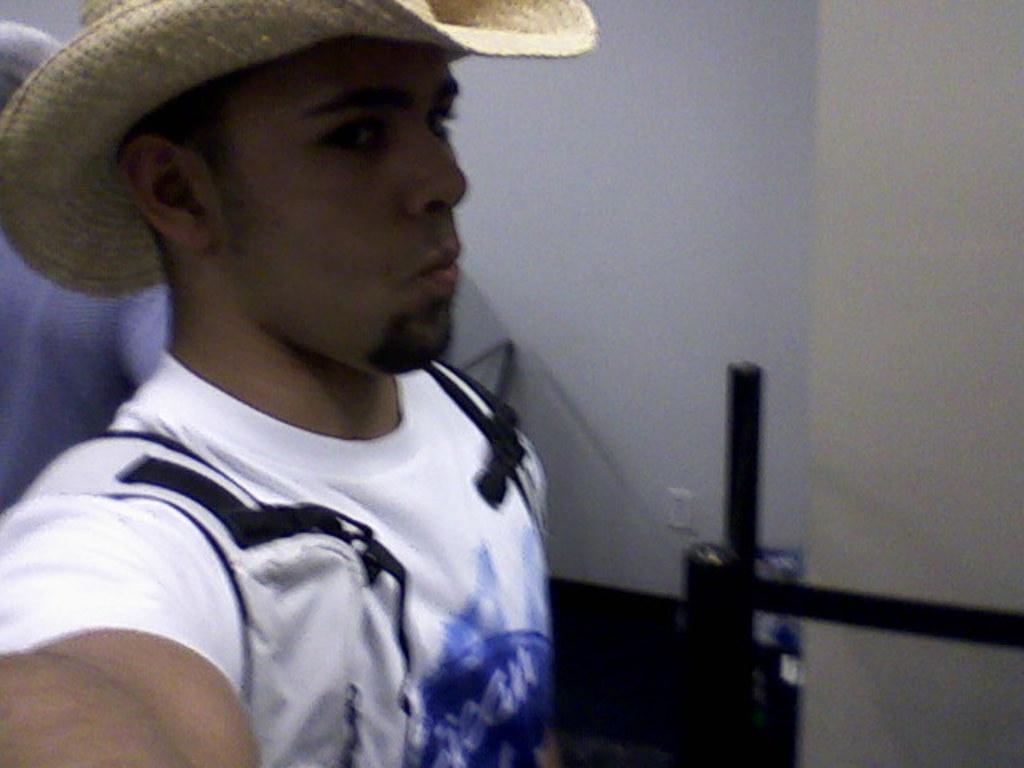Can you describe this image briefly? This image is taken indoors. In the background there is a wall. On the left side of the image there is a man and he has worn a hat. 